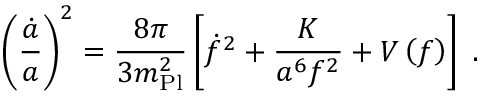<formula> <loc_0><loc_0><loc_500><loc_500>\left ( { \frac { \dot { a } } { a } } \right ) ^ { 2 } = { \frac { 8 \pi } { 3 m _ { P l } ^ { 2 } } } \left [ \dot { f } ^ { 2 } + { \frac { K } { a ^ { 6 } f ^ { 2 } } } + V \left ( f \right ) \right ] \, .</formula> 